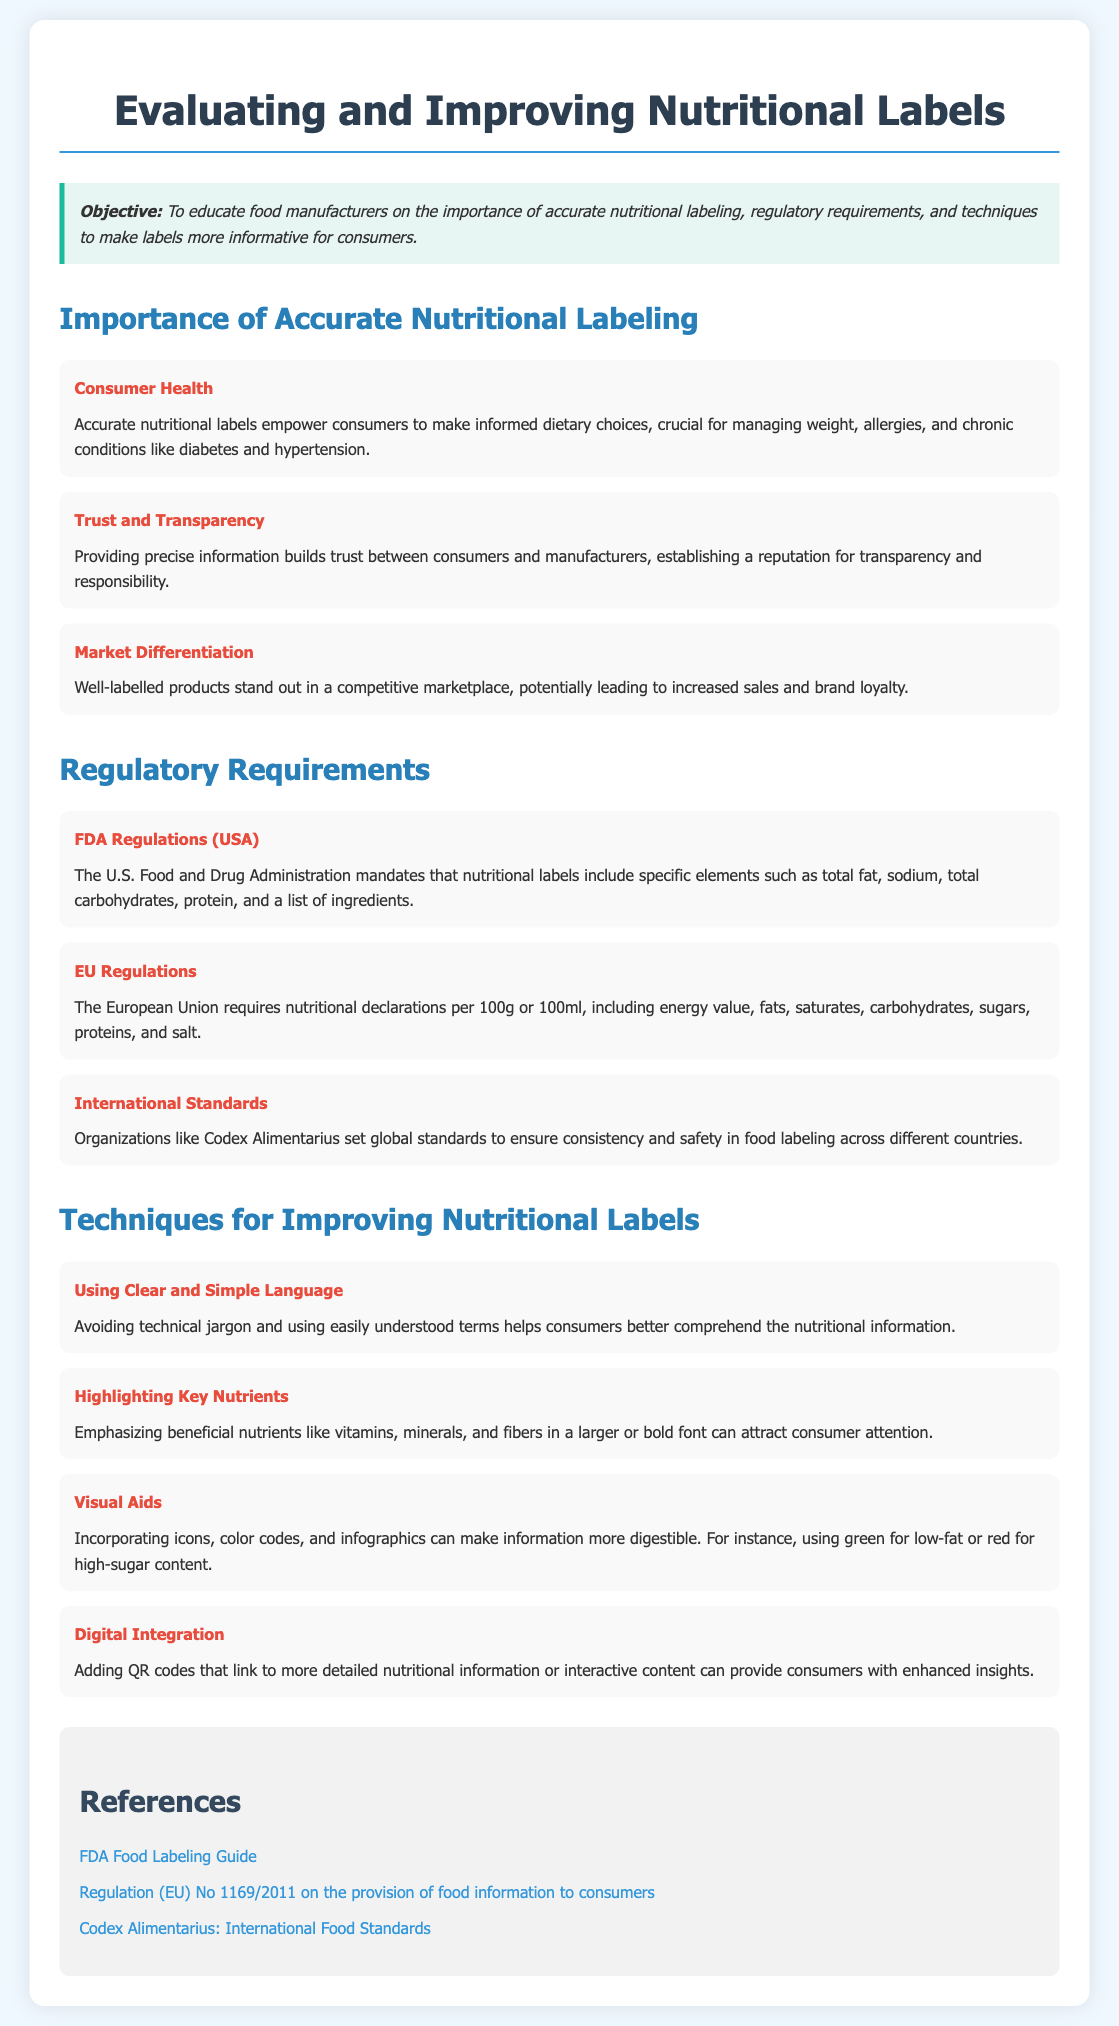What is the primary objective of the lesson plan? The objective outlines the main goal of the lesson, which is to educate food manufacturers on the importance of accurate nutritional labeling and techniques to improve labels for consumers.
Answer: To educate food manufacturers on the importance of accurate nutritional labeling, regulatory requirements, and techniques to make labels more informative for consumers What regulatory body mandates nutritional labels in the USA? The document specifies that the FDA is responsible for the regulations concerning nutritional labels in the United States.
Answer: FDA What does the EU require for nutritional declarations? The document explains that the European Union mandates nutritional declarations to be per 100g or 100ml and lists specific nutritional elements.
Answer: per 100g or 100ml Name one technique for improving nutritional labels mentioned in the document. The document lists various techniques, one of which is to highlight key nutrients to attract consumer attention.
Answer: Highlighting Key Nutrients What color is suggested for low-fat products? The document recommends using specific colors such as green to indicate low-fat content.
Answer: Green Why is accurate nutritional labeling important for consumer health? The document states that accurate labels enable consumers to make informed dietary choices, which is vital for managing health-related issues.
Answer: Empower consumers to make informed dietary choices What role does trust play in nutritional labeling according to the lesson plan? The document indicates that trust is built through precise information, leading to a better reputation for manufacturers.
Answer: Builds trust Which organization sets global standards for food labeling mentioned in the lesson plan? The document refers to Codex Alimentarius as the organization that sets international food standards for labeling.
Answer: Codex Alimentarius 